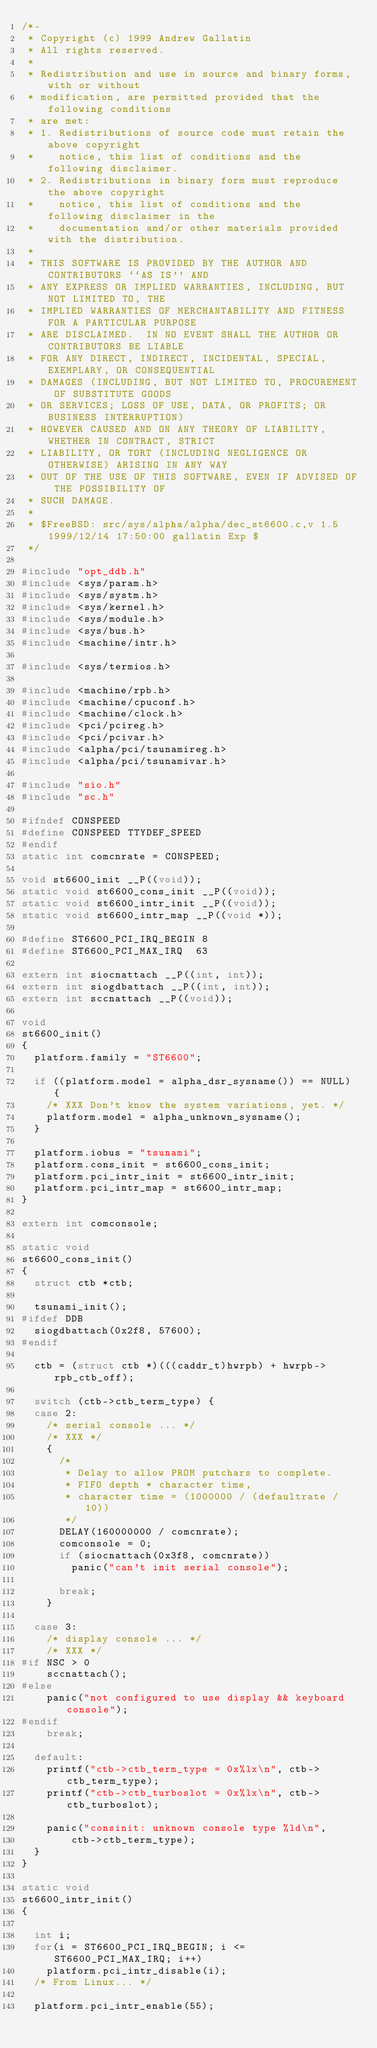Convert code to text. <code><loc_0><loc_0><loc_500><loc_500><_C_>/*-
 * Copyright (c) 1999 Andrew Gallatin
 * All rights reserved.
 *
 * Redistribution and use in source and binary forms, with or without
 * modification, are permitted provided that the following conditions
 * are met:
 * 1. Redistributions of source code must retain the above copyright
 *    notice, this list of conditions and the following disclaimer.
 * 2. Redistributions in binary form must reproduce the above copyright
 *    notice, this list of conditions and the following disclaimer in the
 *    documentation and/or other materials provided with the distribution.
 *
 * THIS SOFTWARE IS PROVIDED BY THE AUTHOR AND CONTRIBUTORS ``AS IS'' AND
 * ANY EXPRESS OR IMPLIED WARRANTIES, INCLUDING, BUT NOT LIMITED TO, THE
 * IMPLIED WARRANTIES OF MERCHANTABILITY AND FITNESS FOR A PARTICULAR PURPOSE
 * ARE DISCLAIMED.  IN NO EVENT SHALL THE AUTHOR OR CONTRIBUTORS BE LIABLE
 * FOR ANY DIRECT, INDIRECT, INCIDENTAL, SPECIAL, EXEMPLARY, OR CONSEQUENTIAL
 * DAMAGES (INCLUDING, BUT NOT LIMITED TO, PROCUREMENT OF SUBSTITUTE GOODS
 * OR SERVICES; LOSS OF USE, DATA, OR PROFITS; OR BUSINESS INTERRUPTION)
 * HOWEVER CAUSED AND ON ANY THEORY OF LIABILITY, WHETHER IN CONTRACT, STRICT
 * LIABILITY, OR TORT (INCLUDING NEGLIGENCE OR OTHERWISE) ARISING IN ANY WAY
 * OUT OF THE USE OF THIS SOFTWARE, EVEN IF ADVISED OF THE POSSIBILITY OF
 * SUCH DAMAGE.
 *
 * $FreeBSD: src/sys/alpha/alpha/dec_st6600.c,v 1.5 1999/12/14 17:50:00 gallatin Exp $
 */

#include "opt_ddb.h"
#include <sys/param.h>
#include <sys/systm.h>
#include <sys/kernel.h>
#include <sys/module.h>
#include <sys/bus.h>
#include <machine/intr.h>

#include <sys/termios.h>

#include <machine/rpb.h>
#include <machine/cpuconf.h>
#include <machine/clock.h>
#include <pci/pcireg.h>
#include <pci/pcivar.h>
#include <alpha/pci/tsunamireg.h>
#include <alpha/pci/tsunamivar.h>

#include "sio.h"
#include "sc.h"

#ifndef CONSPEED
#define CONSPEED TTYDEF_SPEED
#endif
static int comcnrate = CONSPEED;

void st6600_init __P((void));
static void st6600_cons_init __P((void));
static void st6600_intr_init __P((void));
static void st6600_intr_map __P((void *));

#define ST6600_PCI_IRQ_BEGIN 8
#define ST6600_PCI_MAX_IRQ  63

extern int siocnattach __P((int, int));
extern int siogdbattach __P((int, int));
extern int sccnattach __P((void));

void
st6600_init()
{
	platform.family = "ST6600";

	if ((platform.model = alpha_dsr_sysname()) == NULL) {
		/* XXX Don't know the system variations, yet. */
		platform.model = alpha_unknown_sysname();
	}

	platform.iobus = "tsunami";
	platform.cons_init = st6600_cons_init;
	platform.pci_intr_init = st6600_intr_init;
	platform.pci_intr_map = st6600_intr_map;
}

extern int comconsole;

static void
st6600_cons_init()
{
	struct ctb *ctb;

	tsunami_init();
#ifdef DDB
	siogdbattach(0x2f8, 57600);
#endif

	ctb = (struct ctb *)(((caddr_t)hwrpb) + hwrpb->rpb_ctb_off);

	switch (ctb->ctb_term_type) {
	case 2: 
		/* serial console ... */
		/* XXX */
		{
			/*
			 * Delay to allow PROM putchars to complete.
			 * FIFO depth * character time,
			 * character time = (1000000 / (defaultrate / 10))
			 */
			DELAY(160000000 / comcnrate);
			comconsole = 0;
			if (siocnattach(0x3f8, comcnrate))
				panic("can't init serial console");

			break;
		}

	case 3:
		/* display console ... */
		/* XXX */
#if NSC > 0
		sccnattach();
#else
		panic("not configured to use display && keyboard console");
#endif
		break;

	default:
		printf("ctb->ctb_term_type = 0x%lx\n", ctb->ctb_term_type);
		printf("ctb->ctb_turboslot = 0x%lx\n", ctb->ctb_turboslot);

		panic("consinit: unknown console type %ld\n",
		    ctb->ctb_term_type);
	}
}

static void
st6600_intr_init()
{

	int i;
	for(i = ST6600_PCI_IRQ_BEGIN; i <= ST6600_PCI_MAX_IRQ; i++)
		platform.pci_intr_disable(i);
	/* From Linux... */

	platform.pci_intr_enable(55);	</code> 